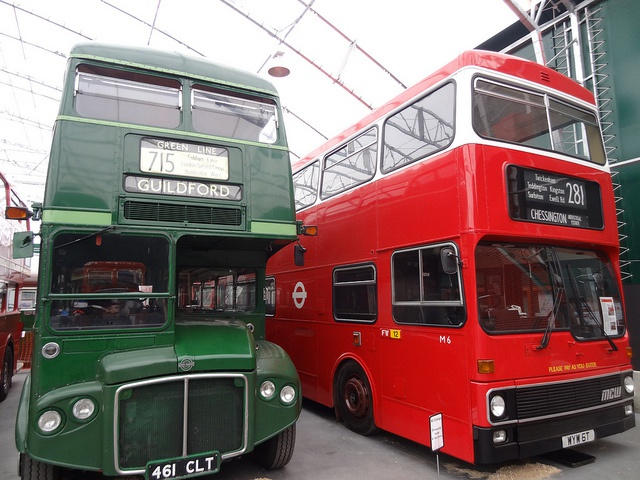Describe the objects in this image and their specific colors. I can see bus in darkgray, black, brown, and maroon tones, bus in darkgray, black, darkgreen, and gray tones, and bus in darkgray, white, maroon, and black tones in this image. 